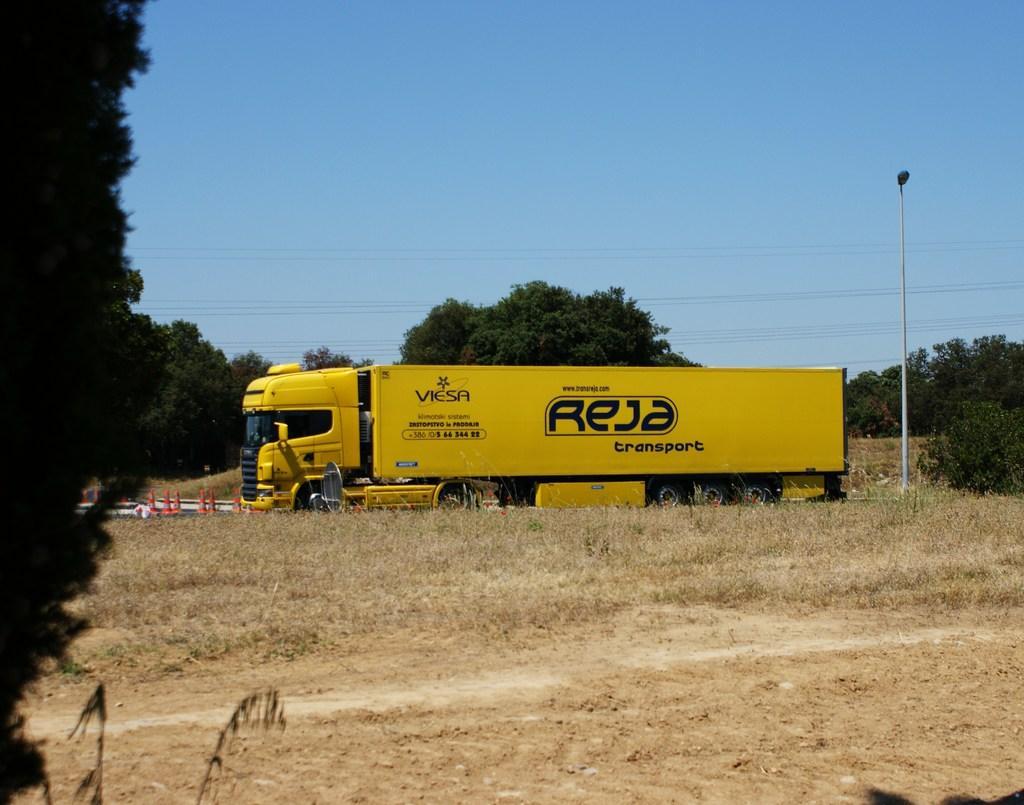In one or two sentences, can you explain what this image depicts? In this image I can see a vehicle in yellow color. Background I can see few trees in green color, a light pole and sky in blue color. 